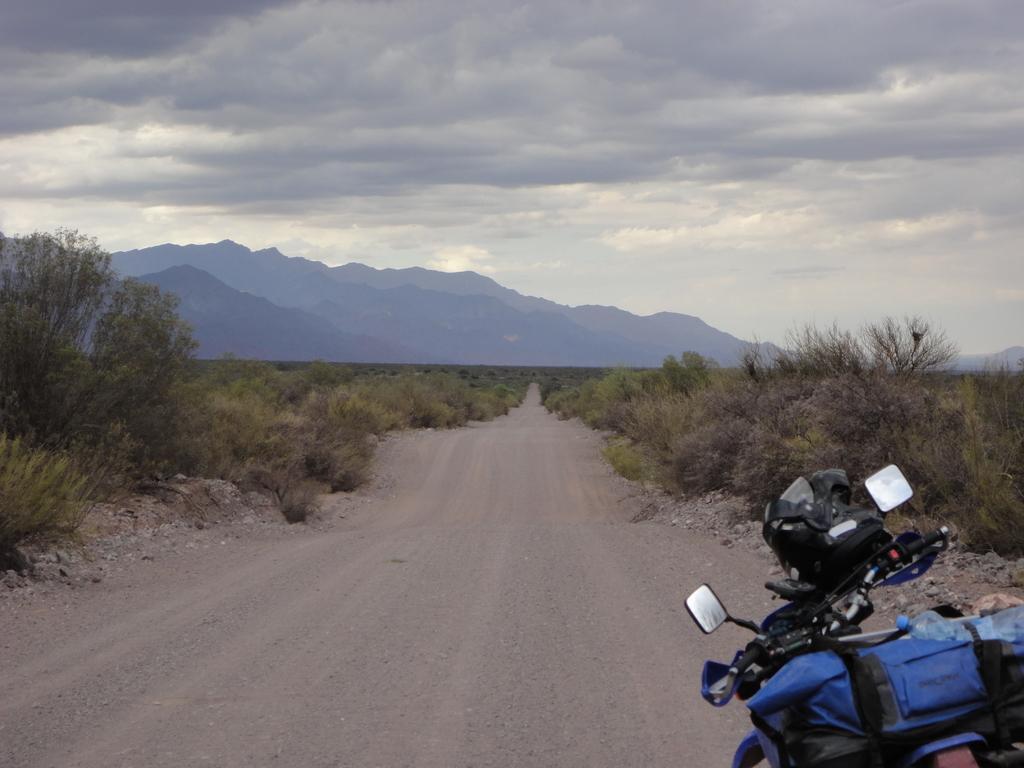How would you summarize this image in a sentence or two? In this image at the bottom, there is a bike on that there is a bottle and helmet. In the middle there are plants and trees. In the background there are hills, sky and clouds. 